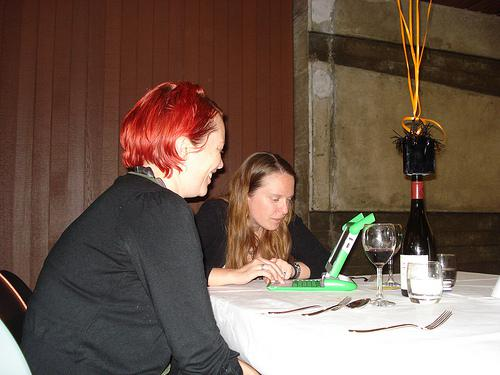Question: where are they sitting?
Choices:
A. Bench.
B. Sofa.
C. In a chair.
D. Bed.
Answer with the letter. Answer: C Question: what is in the picture?
Choices:
A. Cats.
B. Dogs.
C. Elephants.
D. People.
Answer with the letter. Answer: D Question: what color hair do they have?
Choices:
A. Red and brown.
B. Blonde and raven.
C. Silver and white.
D. Salt and pepper, and woody.
Answer with the letter. Answer: A Question: how many people?
Choices:
A. 3.
B. 4.
C. 2.
D. 5.
Answer with the letter. Answer: C 